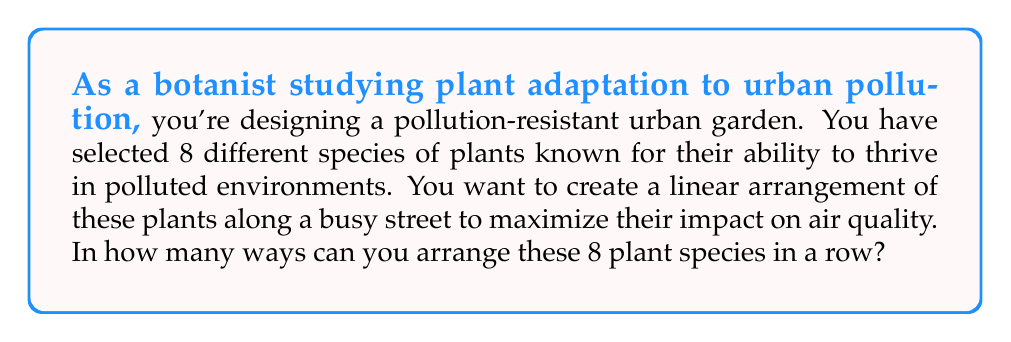Can you answer this question? This problem is a classic permutation question. We need to determine the number of ways to arrange 8 distinct objects (in this case, plant species) in a line.

The formula for permutations of n distinct objects is:

$$P(n) = n!$$

Where $n!$ represents the factorial of $n$.

In this case, we have 8 plant species, so $n = 8$.

Let's calculate step by step:

$$\begin{align*}
P(8) &= 8! \\
&= 8 \times 7 \times 6 \times 5 \times 4 \times 3 \times 2 \times 1 \\
&= 40,320
\end{align*}$$

Each number in this calculation represents the choice for each position in the row:
- For the first position, we have 8 choices
- For the second position, we have 7 remaining choices
- For the third position, we have 6 remaining choices
- And so on, until we place the last plant

The product of all these choices gives us the total number of possible arrangements.
Answer: There are $40,320$ ways to arrange 8 different pollution-resistant plant species in a row. 